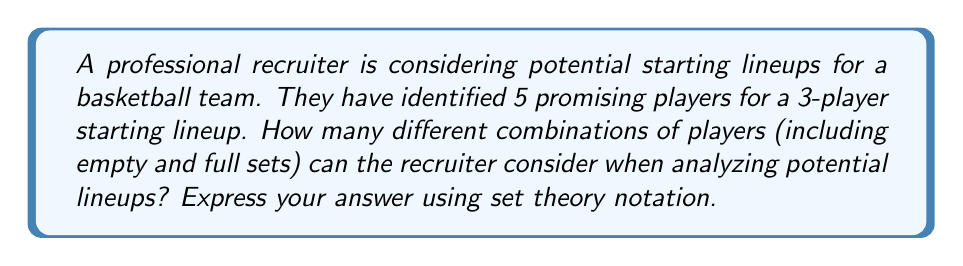Can you answer this question? To solve this problem, we need to compute the power set of the set of 5 players. The power set is the set of all possible subsets of a given set, including the empty set and the set itself.

Let's approach this step-by-step:

1) First, let's define our set of players:
   Let $S = \{p_1, p_2, p_3, p_4, p_5\}$ where each $p_i$ represents a player.

2) The power set of $S$, denoted as $P(S)$, will contain:
   - The empty set $\{\}$
   - All 1-player subsets: $\{p_1\}, \{p_2\}, \{p_3\}, \{p_4\}, \{p_5\}$
   - All 2-player subsets: $\{p_1,p_2\}, \{p_1,p_3\}, ..., \{p_4,p_5\}$
   - All 3-player subsets: $\{p_1,p_2,p_3\}, \{p_1,p_2,p_4\}, ..., \{p_3,p_4,p_5\}$
   - All 4-player subsets: $\{p_1,p_2,p_3,p_4\}, ..., \{p_2,p_3,p_4,p_5\}$
   - The full set: $\{p_1,p_2,p_3,p_4,p_5\}$

3) To count the number of elements in the power set, we can use the formula:
   $$|P(S)| = 2^n$$
   where $n$ is the number of elements in the original set $S$.

4) In this case, $n = 5$, so:
   $$|P(S)| = 2^5 = 32$$

Therefore, the recruiter can consider 32 different combinations of players when analyzing potential lineups.
Answer: $|P(S)| = 2^5 = 32$ 